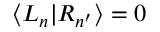<formula> <loc_0><loc_0><loc_500><loc_500>\langle L _ { n } | R _ { n ^ { \prime } } \rangle = 0</formula> 